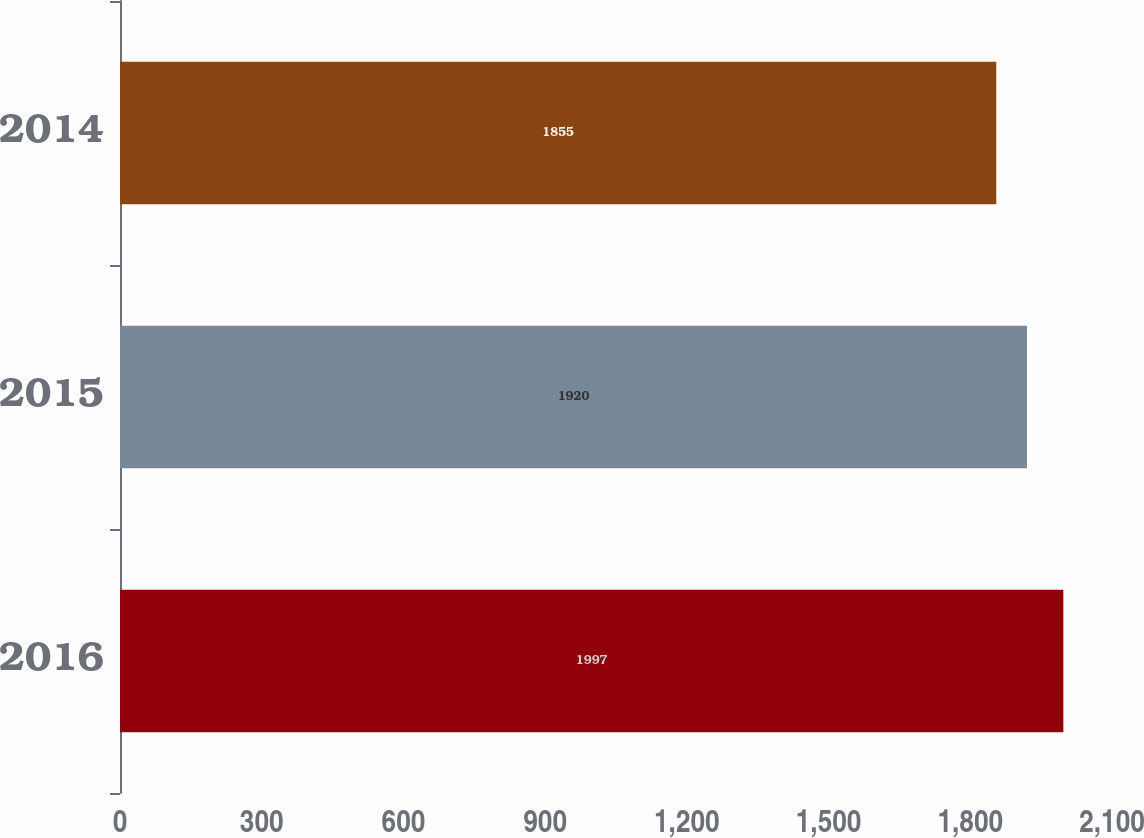<chart> <loc_0><loc_0><loc_500><loc_500><bar_chart><fcel>2016<fcel>2015<fcel>2014<nl><fcel>1997<fcel>1920<fcel>1855<nl></chart> 